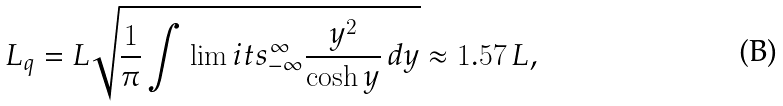Convert formula to latex. <formula><loc_0><loc_0><loc_500><loc_500>L _ { q } = L \sqrt { \frac { 1 } { \pi } \int \lim i t s _ { - \infty } ^ { \infty } \frac { y ^ { 2 } } { \cosh { y } } \, d y } \approx 1 . 5 7 \, L ,</formula> 